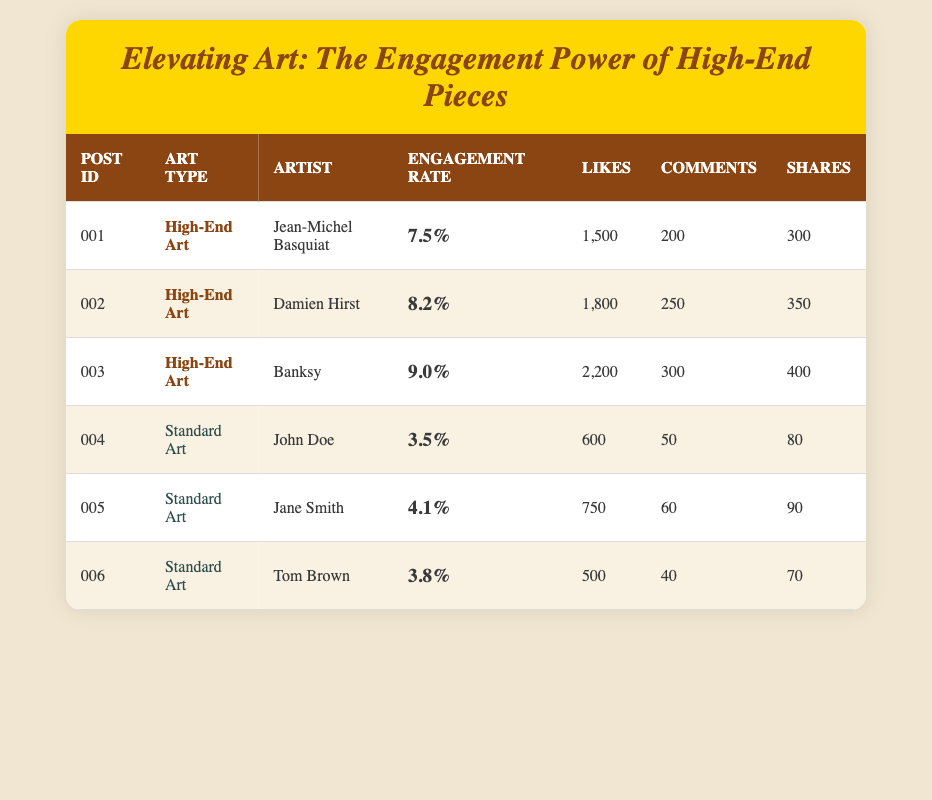What is the engagement rate of the post featuring Banksy's work? The engagement rate for Banksy's post is listed in the table under the "Engagement Rate" column for post ID 003, which shows 9.0%.
Answer: 9.0% Which artist had the highest number of likes? In the table, looking at the "Likes" column, Banksy's post has the highest likes with 2200 likes.
Answer: Banksy How many comments did the post by Jane Smith receive? The table shows that Jane Smith's post (post ID 005) received 60 comments under the "Comments" column.
Answer: 60 Is it true that all High-End Art posts have an engagement rate higher than 5%? The engagement rates of High-End Art posts are 7.5%, 8.2%, and 9.0%. All these values are above 5%, confirming that the statement is true.
Answer: Yes What is the average engagement rate for Standard Art posts? First, we take the engagement rates of Standard Art: 3.5%, 4.1%, and 3.8%. Next, we sum these values: 3.5 + 4.1 + 3.8 = 11.4. Finally, divide by the number of posts (3): 11.4 / 3 = 3.8.
Answer: 3.8 What is the difference in engagement rates between the highest and lowest posts? The highest engagement rate is from Banksy (9.0%) and the lowest is from John Doe (3.5%). The difference is calculated as 9.0 - 3.5 = 5.5.
Answer: 5.5 Does the data indicate that High-End Art generally outperforms Standard Art in engagement? Yes, comparing the highest engagement rate of 9.0% (Banksy) to the highest of Standard Art at 4.1% (Jane Smith), High-End Art posts show significantly higher engagement rates overall.
Answer: Yes How many shares did the High-End Art post by Damien Hirst get? Looking at the table under the "Shares" column for post ID 002, it shows that Damien Hirst’s post received 350 shares.
Answer: 350 What is the total number of likes for all posts featuring Standard Art? For Standard Art posts, the likes are 600, 750, and 500. Summing these gives 600 + 750 + 500 = 1850 likes total from Standard Art.
Answer: 1850 